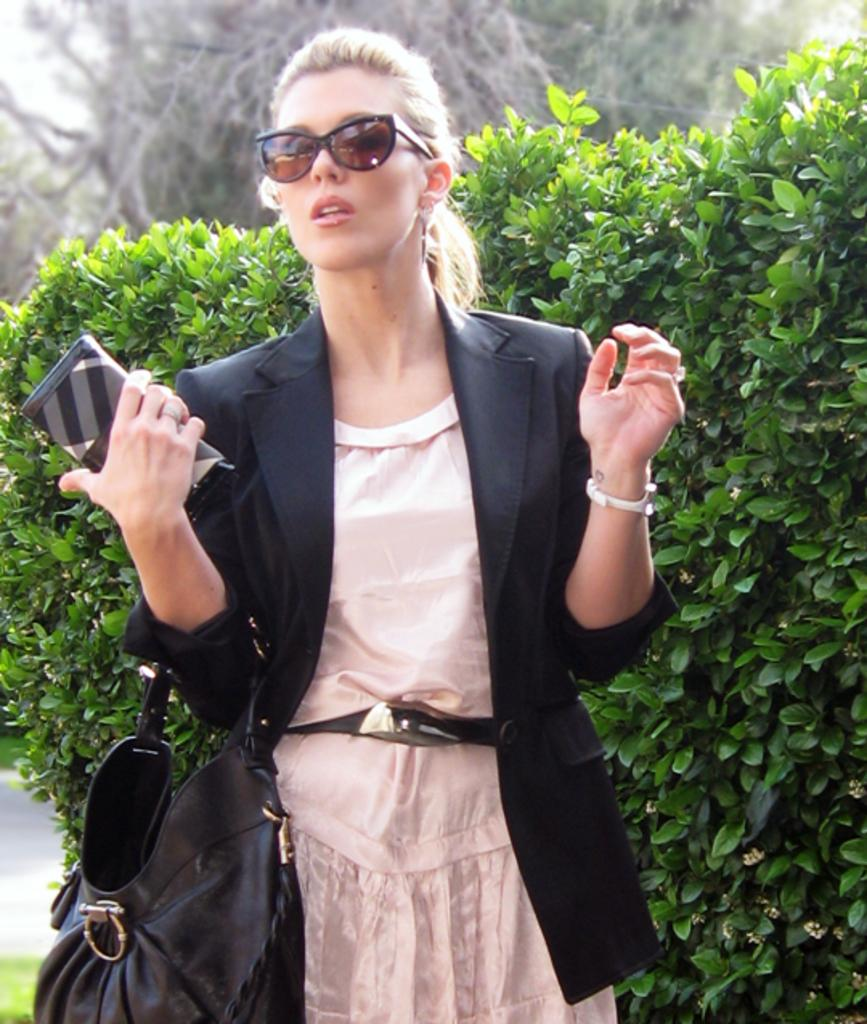Who is present in the image? There is a woman in the image. What is the woman wearing on her face? The woman is wearing shades. What type of clothing is the woman wearing on her upper body? The woman is wearing a black jacket. What can be seen in the background of the image? There are plants in the background of the image. What object is the woman holding in her hand? The woman is holding a mobile. What type of scarf is the woman wearing in the image? There is no scarf present in the image; the woman is wearing shades and a black jacket. How many ants can be seen crawling on the woman's arm in the image? There are no ants present in the image. 